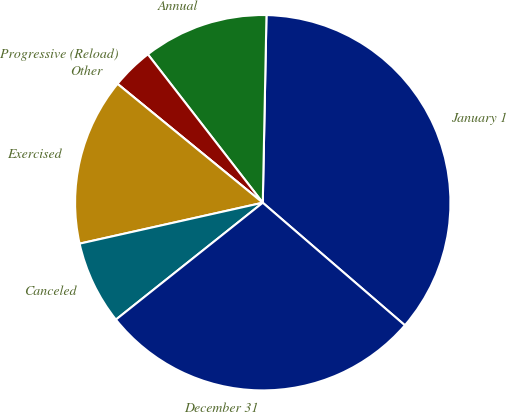Convert chart. <chart><loc_0><loc_0><loc_500><loc_500><pie_chart><fcel>January 1<fcel>Annual<fcel>Progressive (Reload)<fcel>Other<fcel>Exercised<fcel>Canceled<fcel>December 31<nl><fcel>36.01%<fcel>10.8%<fcel>3.6%<fcel>0.0%<fcel>14.41%<fcel>7.2%<fcel>27.97%<nl></chart> 